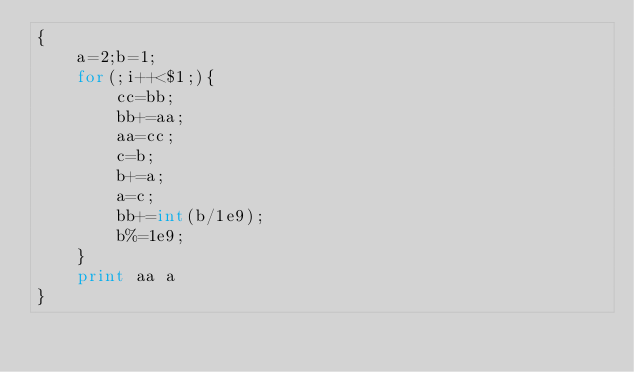Convert code to text. <code><loc_0><loc_0><loc_500><loc_500><_Awk_>{
	a=2;b=1;
	for(;i++<$1;){
		cc=bb;
		bb+=aa;
		aa=cc;
		c=b;
		b+=a;
		a=c;
		bb+=int(b/1e9);
		b%=1e9;
	}
	print aa a
}
</code> 